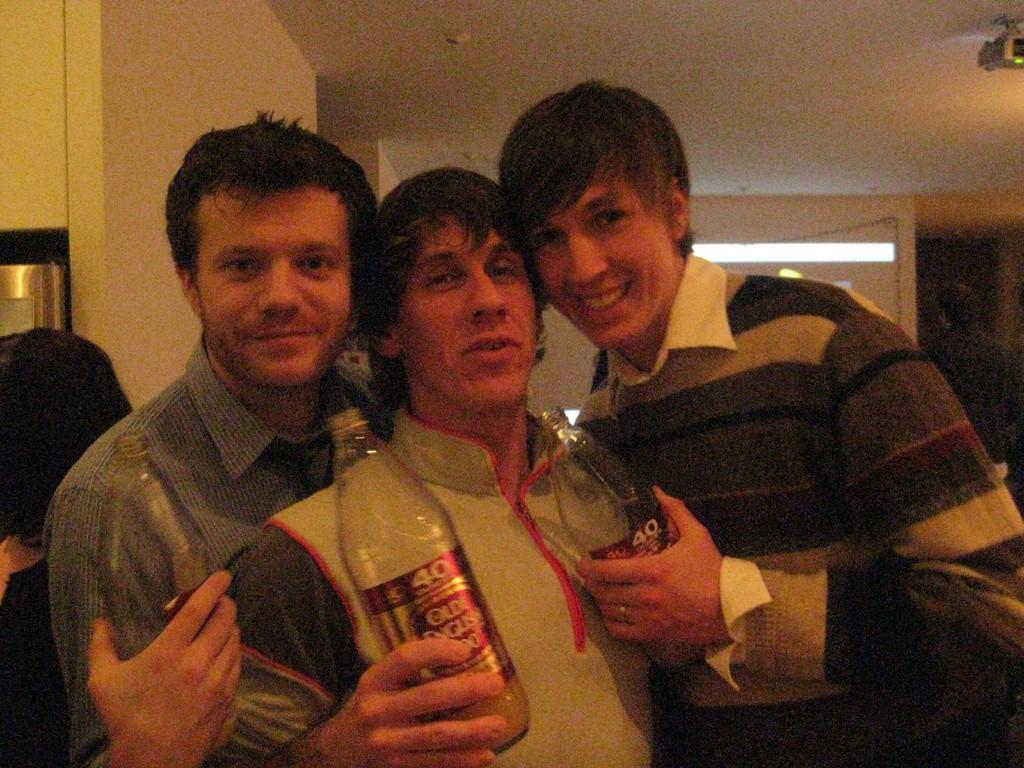How many people are in the image? There are three people in the image. What are the people doing in the image? The people are standing and laughing. What are the people holding in their hands? The people are holding bottles in their hands. What type of train can be seen in the image? There is no train present in the image; it features three people standing and laughing while holding bottles. How many snakes are visible in the image? There are no snakes present in the image. 